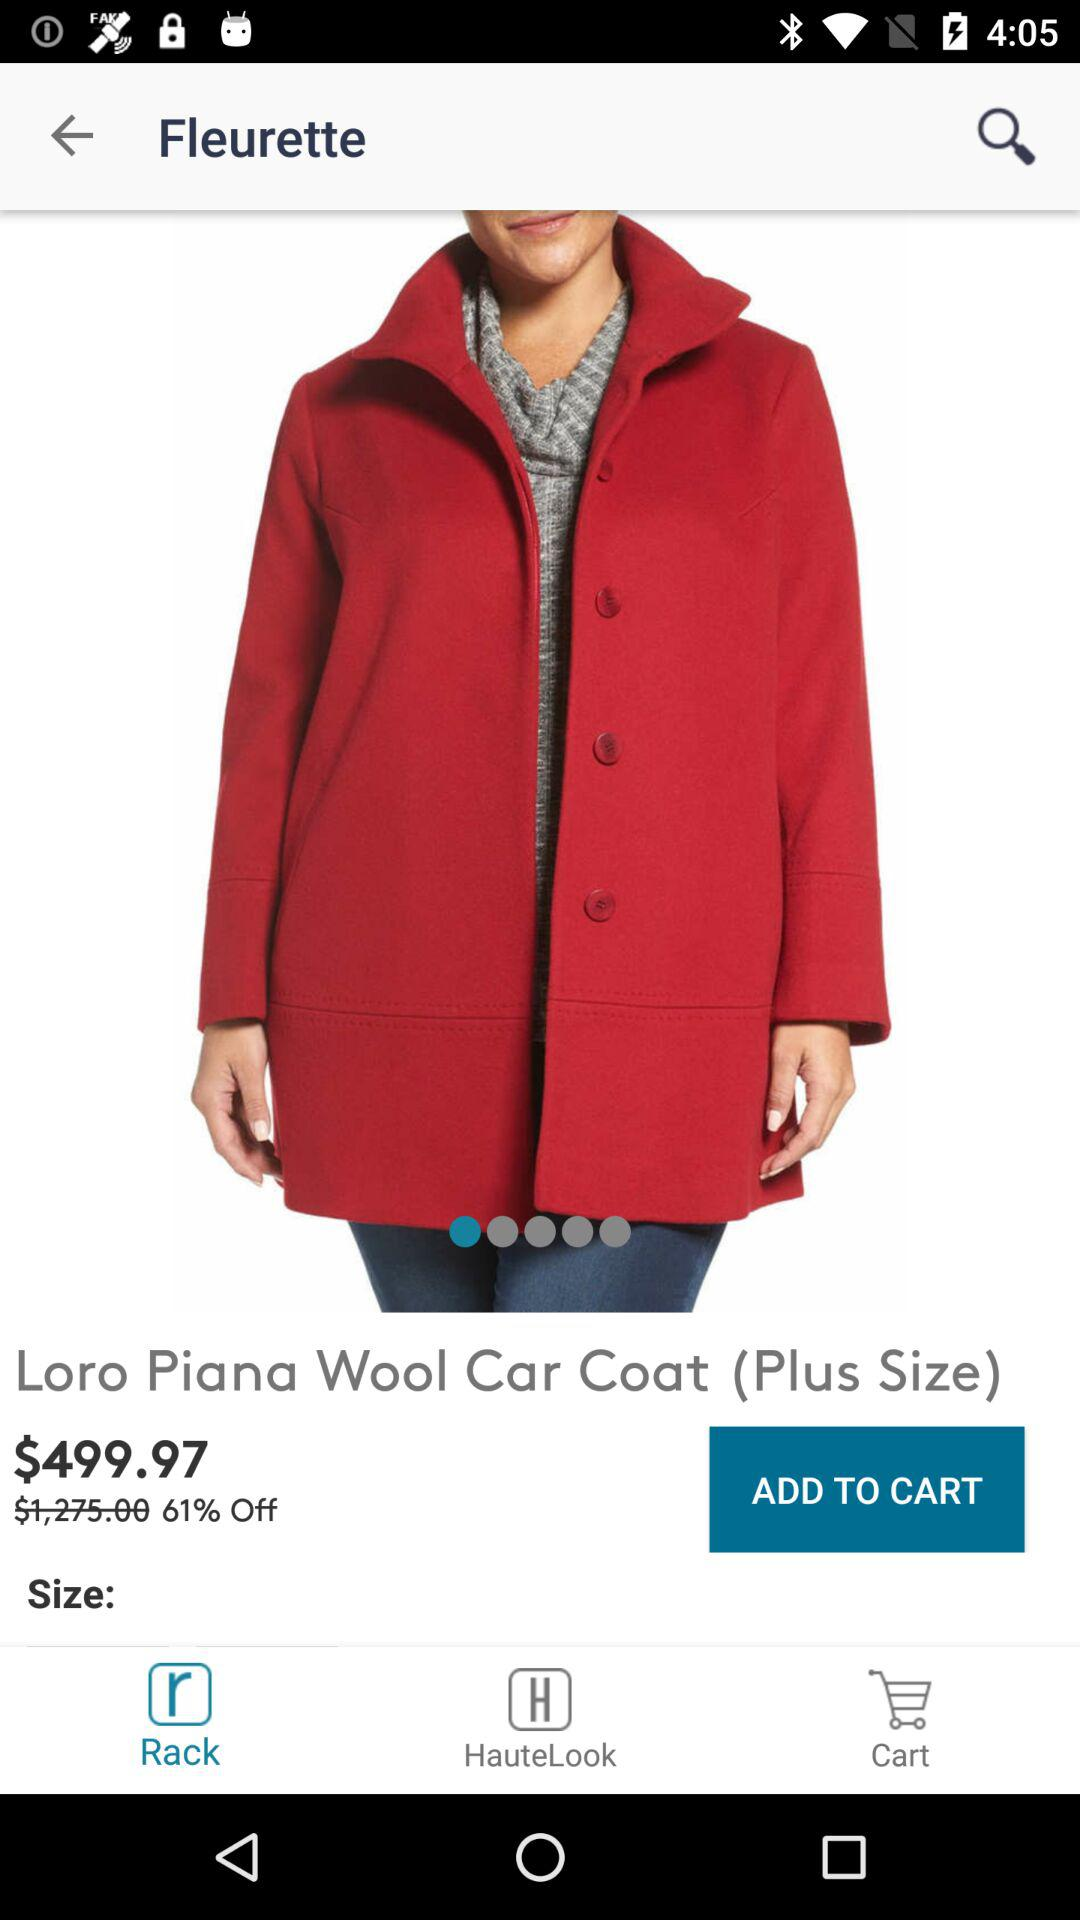How much is the original price of the coat?
Answer the question using a single word or phrase. $1,275.00 